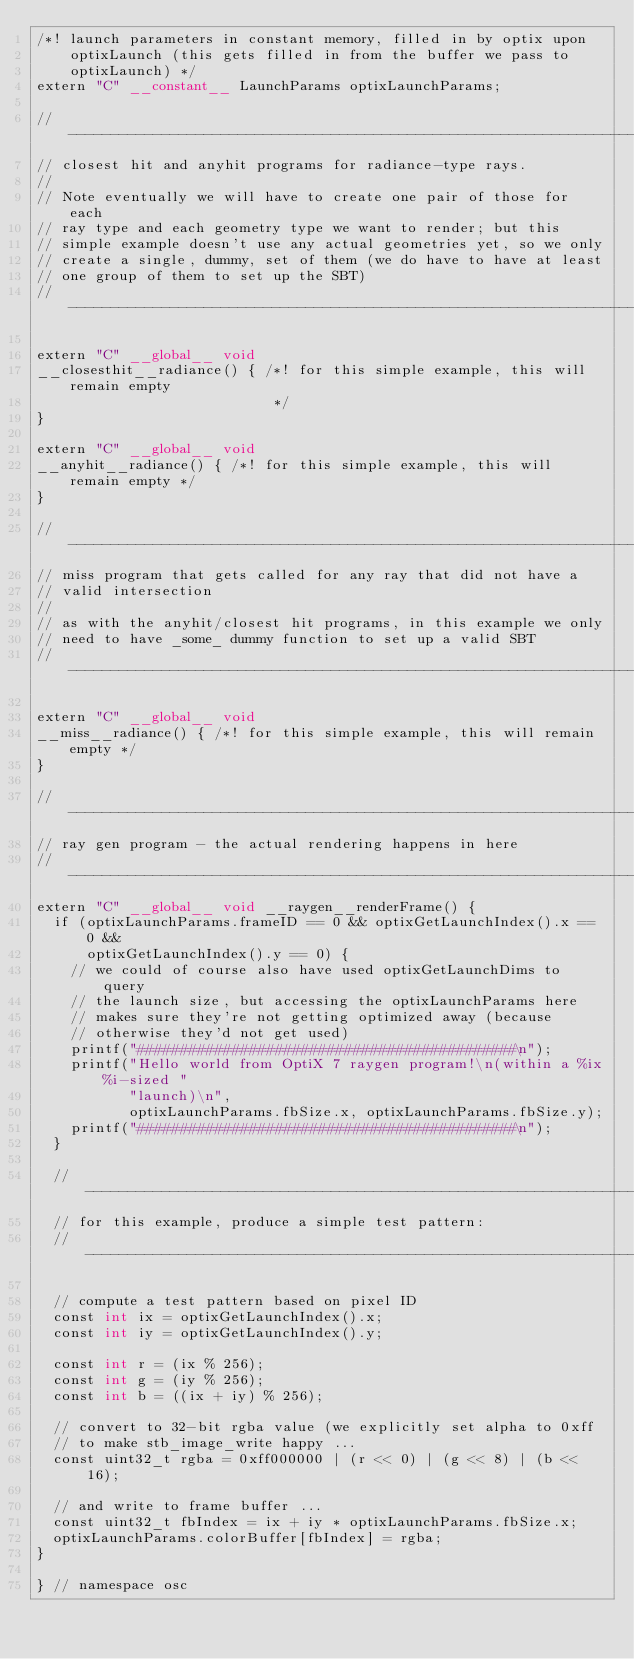<code> <loc_0><loc_0><loc_500><loc_500><_Cuda_>/*! launch parameters in constant memory, filled in by optix upon
    optixLaunch (this gets filled in from the buffer we pass to
    optixLaunch) */
extern "C" __constant__ LaunchParams optixLaunchParams;

//------------------------------------------------------------------------------
// closest hit and anyhit programs for radiance-type rays.
//
// Note eventually we will have to create one pair of those for each
// ray type and each geometry type we want to render; but this
// simple example doesn't use any actual geometries yet, so we only
// create a single, dummy, set of them (we do have to have at least
// one group of them to set up the SBT)
//------------------------------------------------------------------------------

extern "C" __global__ void
__closesthit__radiance() { /*! for this simple example, this will remain empty
                            */
}

extern "C" __global__ void
__anyhit__radiance() { /*! for this simple example, this will remain empty */
}

//------------------------------------------------------------------------------
// miss program that gets called for any ray that did not have a
// valid intersection
//
// as with the anyhit/closest hit programs, in this example we only
// need to have _some_ dummy function to set up a valid SBT
// ------------------------------------------------------------------------------

extern "C" __global__ void
__miss__radiance() { /*! for this simple example, this will remain empty */
}

//------------------------------------------------------------------------------
// ray gen program - the actual rendering happens in here
//------------------------------------------------------------------------------
extern "C" __global__ void __raygen__renderFrame() {
  if (optixLaunchParams.frameID == 0 && optixGetLaunchIndex().x == 0 &&
      optixGetLaunchIndex().y == 0) {
    // we could of course also have used optixGetLaunchDims to query
    // the launch size, but accessing the optixLaunchParams here
    // makes sure they're not getting optimized away (because
    // otherwise they'd not get used)
    printf("############################################\n");
    printf("Hello world from OptiX 7 raygen program!\n(within a %ix%i-sized "
           "launch)\n",
           optixLaunchParams.fbSize.x, optixLaunchParams.fbSize.y);
    printf("############################################\n");
  }

  // ------------------------------------------------------------------
  // for this example, produce a simple test pattern:
  // ------------------------------------------------------------------

  // compute a test pattern based on pixel ID
  const int ix = optixGetLaunchIndex().x;
  const int iy = optixGetLaunchIndex().y;

  const int r = (ix % 256);
  const int g = (iy % 256);
  const int b = ((ix + iy) % 256);

  // convert to 32-bit rgba value (we explicitly set alpha to 0xff
  // to make stb_image_write happy ...
  const uint32_t rgba = 0xff000000 | (r << 0) | (g << 8) | (b << 16);

  // and write to frame buffer ...
  const uint32_t fbIndex = ix + iy * optixLaunchParams.fbSize.x;
  optixLaunchParams.colorBuffer[fbIndex] = rgba;
}

} // namespace osc
</code> 